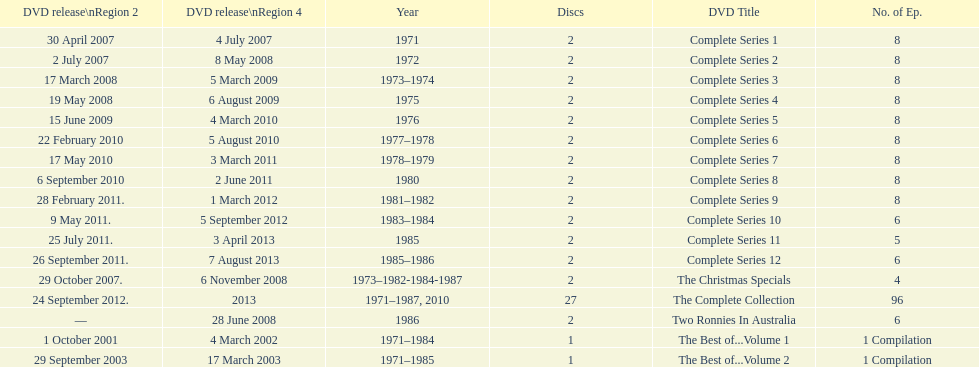Give me the full table as a dictionary. {'header': ['DVD release\\nRegion 2', 'DVD release\\nRegion 4', 'Year', 'Discs', 'DVD Title', 'No. of Ep.'], 'rows': [['30 April 2007', '4 July 2007', '1971', '2', 'Complete Series 1', '8'], ['2 July 2007', '8 May 2008', '1972', '2', 'Complete Series 2', '8'], ['17 March 2008', '5 March 2009', '1973–1974', '2', 'Complete Series 3', '8'], ['19 May 2008', '6 August 2009', '1975', '2', 'Complete Series 4', '8'], ['15 June 2009', '4 March 2010', '1976', '2', 'Complete Series 5', '8'], ['22 February 2010', '5 August 2010', '1977–1978', '2', 'Complete Series 6', '8'], ['17 May 2010', '3 March 2011', '1978–1979', '2', 'Complete Series 7', '8'], ['6 September 2010', '2 June 2011', '1980', '2', 'Complete Series 8', '8'], ['28 February 2011.', '1 March 2012', '1981–1982', '2', 'Complete Series 9', '8'], ['9 May 2011.', '5 September 2012', '1983–1984', '2', 'Complete Series 10', '6'], ['25 July 2011.', '3 April 2013', '1985', '2', 'Complete Series 11', '5'], ['26 September 2011.', '7 August 2013', '1985–1986', '2', 'Complete Series 12', '6'], ['29 October 2007.', '6 November 2008', '1973–1982-1984-1987', '2', 'The Christmas Specials', '4'], ['24 September 2012.', '2013', '1971–1987, 2010', '27', 'The Complete Collection', '96'], ['—', '28 June 2008', '1986', '2', 'Two Ronnies In Australia', '6'], ['1 October 2001', '4 March 2002', '1971–1984', '1', 'The Best of...Volume 1', '1 Compilation'], ['29 September 2003', '17 March 2003', '1971–1985', '1', 'The Best of...Volume 2', '1 Compilation']]} What is the total of all dics listed in the table? 57. 